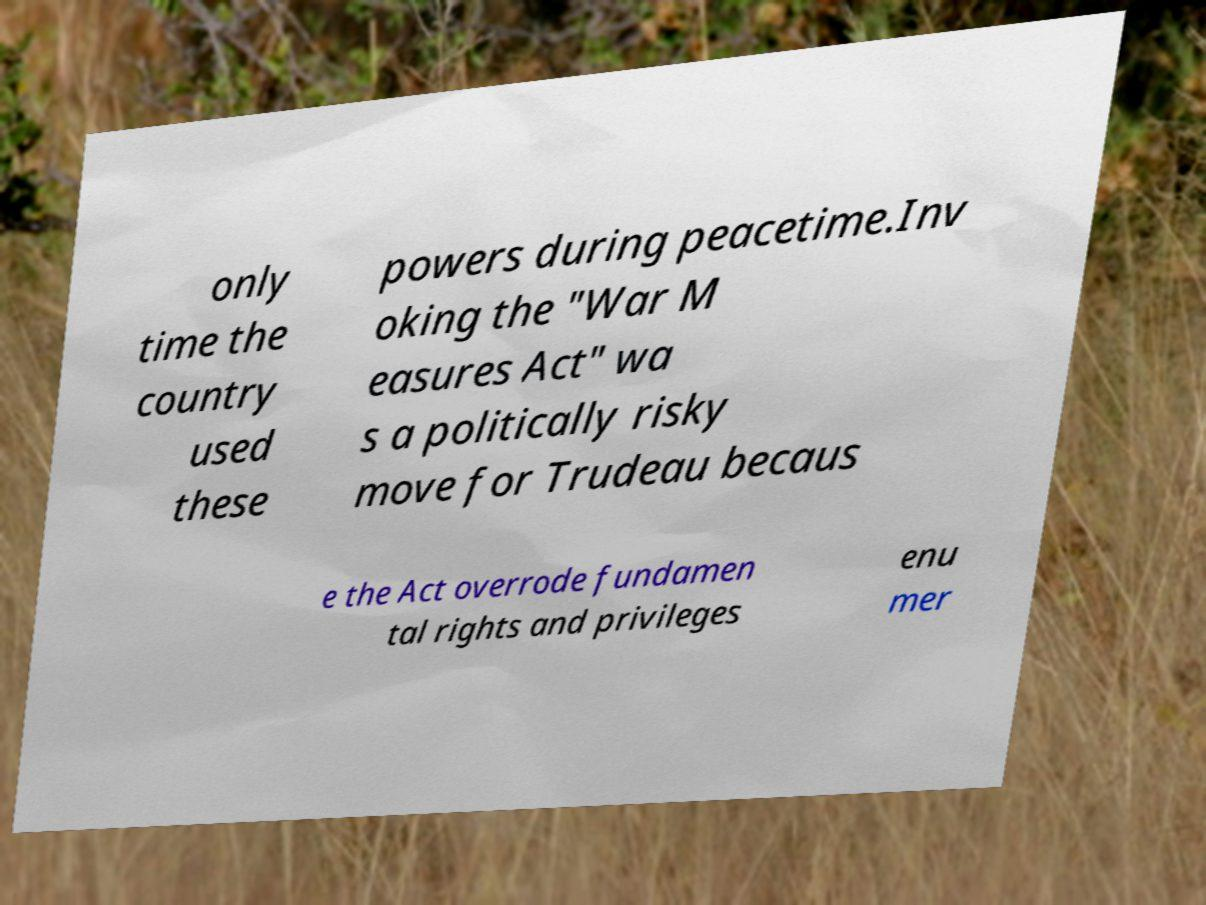Could you extract and type out the text from this image? only time the country used these powers during peacetime.Inv oking the "War M easures Act" wa s a politically risky move for Trudeau becaus e the Act overrode fundamen tal rights and privileges enu mer 